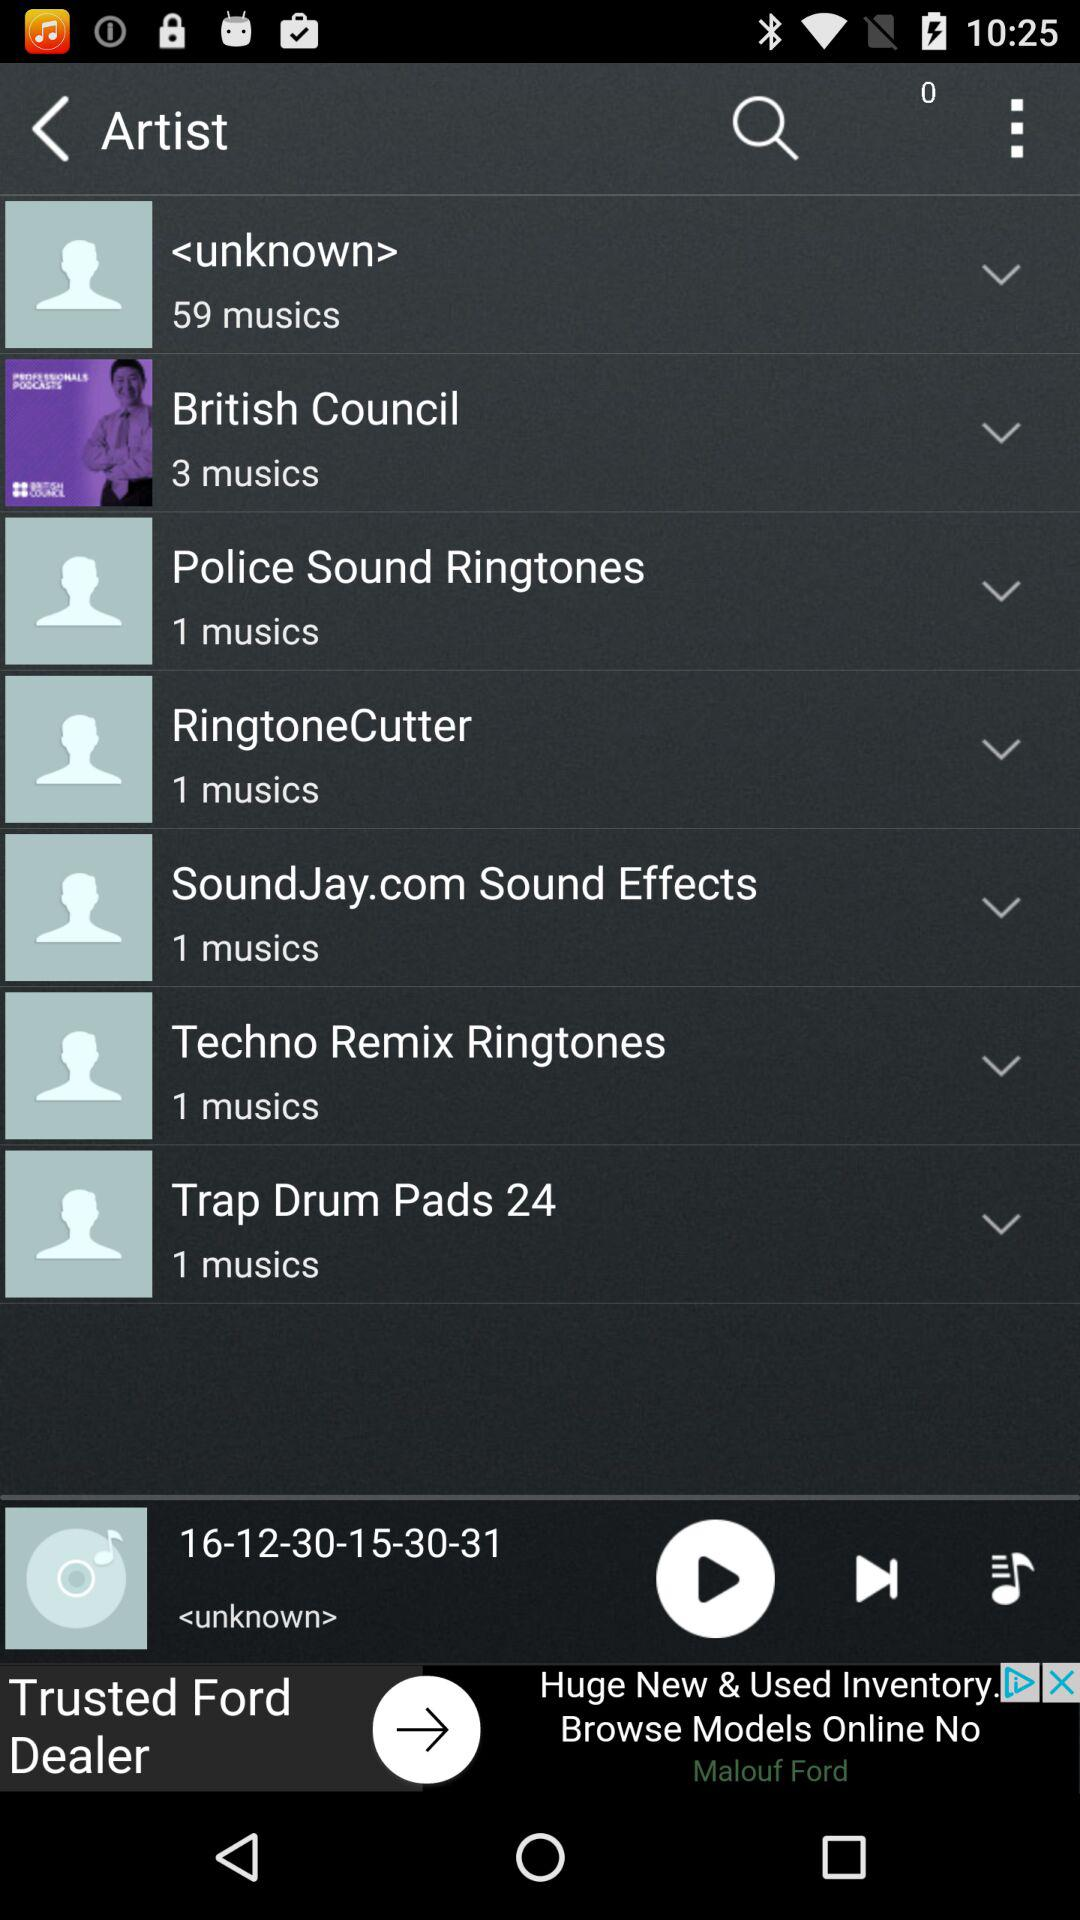What is the number of musics in "RingtoneCutter"? The number of musics is 1. 